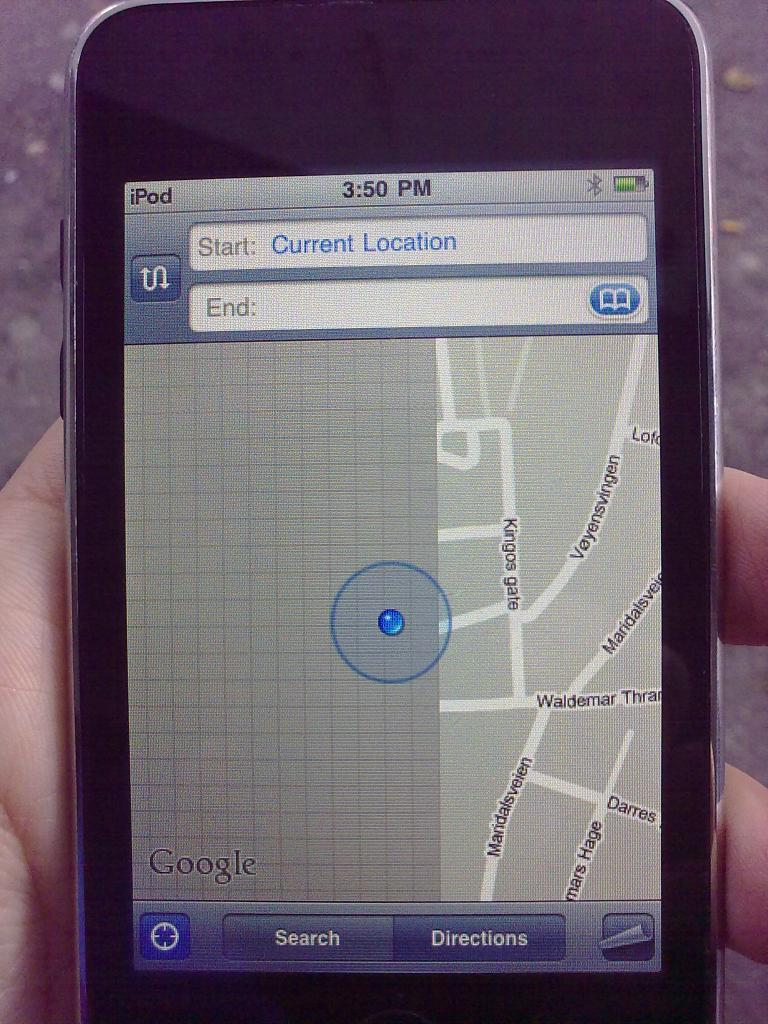<image>
Render a clear and concise summary of the photo. Hand is holding a iphone using a map with the current location 